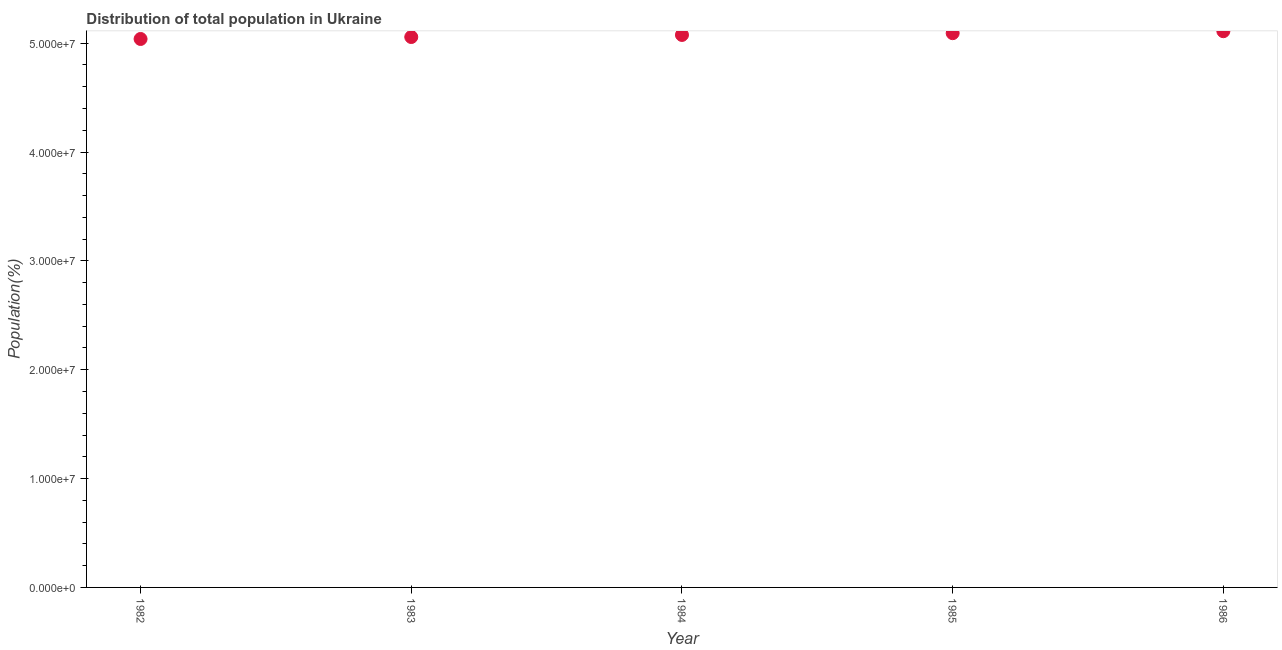What is the population in 1984?
Provide a succinct answer. 5.08e+07. Across all years, what is the maximum population?
Your response must be concise. 5.11e+07. Across all years, what is the minimum population?
Offer a terse response. 5.04e+07. In which year was the population minimum?
Ensure brevity in your answer.  1982. What is the sum of the population?
Give a very brief answer. 2.54e+08. What is the difference between the population in 1984 and 1985?
Keep it short and to the point. -1.63e+05. What is the average population per year?
Provide a short and direct response. 5.07e+07. What is the median population?
Offer a very short reply. 5.08e+07. In how many years, is the population greater than 20000000 %?
Ensure brevity in your answer.  5. What is the ratio of the population in 1984 to that in 1985?
Provide a succinct answer. 1. Is the population in 1983 less than that in 1985?
Your answer should be very brief. Yes. Is the difference between the population in 1985 and 1986 greater than the difference between any two years?
Provide a succinct answer. No. What is the difference between the highest and the second highest population?
Give a very brief answer. 1.80e+05. What is the difference between the highest and the lowest population?
Provide a short and direct response. 7.13e+05. How many years are there in the graph?
Ensure brevity in your answer.  5. What is the difference between two consecutive major ticks on the Y-axis?
Ensure brevity in your answer.  1.00e+07. Are the values on the major ticks of Y-axis written in scientific E-notation?
Ensure brevity in your answer.  Yes. Does the graph contain any zero values?
Give a very brief answer. No. What is the title of the graph?
Your response must be concise. Distribution of total population in Ukraine . What is the label or title of the Y-axis?
Give a very brief answer. Population(%). What is the Population(%) in 1982?
Give a very brief answer. 5.04e+07. What is the Population(%) in 1983?
Keep it short and to the point. 5.06e+07. What is the Population(%) in 1984?
Make the answer very short. 5.08e+07. What is the Population(%) in 1985?
Your answer should be very brief. 5.09e+07. What is the Population(%) in 1986?
Offer a terse response. 5.11e+07. What is the difference between the Population(%) in 1982 and 1983?
Keep it short and to the point. -1.80e+05. What is the difference between the Population(%) in 1982 and 1984?
Provide a succinct answer. -3.70e+05. What is the difference between the Population(%) in 1982 and 1985?
Your answer should be very brief. -5.33e+05. What is the difference between the Population(%) in 1982 and 1986?
Your answer should be very brief. -7.13e+05. What is the difference between the Population(%) in 1983 and 1985?
Your answer should be very brief. -3.53e+05. What is the difference between the Population(%) in 1983 and 1986?
Your response must be concise. -5.33e+05. What is the difference between the Population(%) in 1984 and 1985?
Make the answer very short. -1.63e+05. What is the difference between the Population(%) in 1984 and 1986?
Give a very brief answer. -3.43e+05. What is the ratio of the Population(%) in 1982 to that in 1983?
Ensure brevity in your answer.  1. What is the ratio of the Population(%) in 1982 to that in 1984?
Make the answer very short. 0.99. What is the ratio of the Population(%) in 1982 to that in 1985?
Give a very brief answer. 0.99. What is the ratio of the Population(%) in 1983 to that in 1985?
Your response must be concise. 0.99. What is the ratio of the Population(%) in 1983 to that in 1986?
Provide a succinct answer. 0.99. What is the ratio of the Population(%) in 1984 to that in 1985?
Make the answer very short. 1. What is the ratio of the Population(%) in 1984 to that in 1986?
Keep it short and to the point. 0.99. 